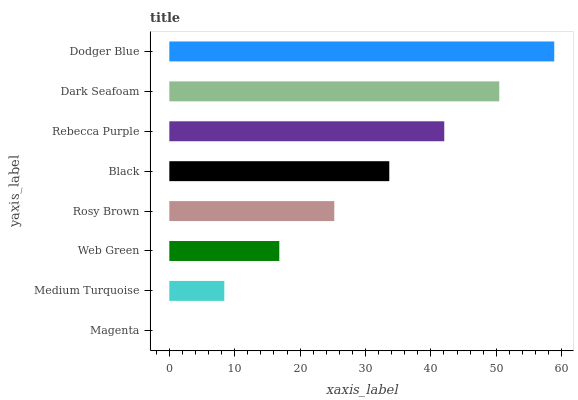Is Magenta the minimum?
Answer yes or no. Yes. Is Dodger Blue the maximum?
Answer yes or no. Yes. Is Medium Turquoise the minimum?
Answer yes or no. No. Is Medium Turquoise the maximum?
Answer yes or no. No. Is Medium Turquoise greater than Magenta?
Answer yes or no. Yes. Is Magenta less than Medium Turquoise?
Answer yes or no. Yes. Is Magenta greater than Medium Turquoise?
Answer yes or no. No. Is Medium Turquoise less than Magenta?
Answer yes or no. No. Is Black the high median?
Answer yes or no. Yes. Is Rosy Brown the low median?
Answer yes or no. Yes. Is Medium Turquoise the high median?
Answer yes or no. No. Is Dodger Blue the low median?
Answer yes or no. No. 